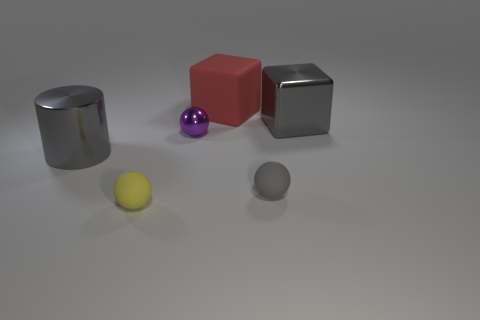Subtract all yellow rubber balls. How many balls are left? 2 Subtract 1 spheres. How many spheres are left? 2 Add 4 blue spheres. How many objects exist? 10 Subtract all cylinders. How many objects are left? 5 Subtract all brown balls. Subtract all red blocks. How many balls are left? 3 Subtract 0 green cubes. How many objects are left? 6 Subtract all red objects. Subtract all big cubes. How many objects are left? 3 Add 1 large shiny blocks. How many large shiny blocks are left? 2 Add 5 small purple things. How many small purple things exist? 6 